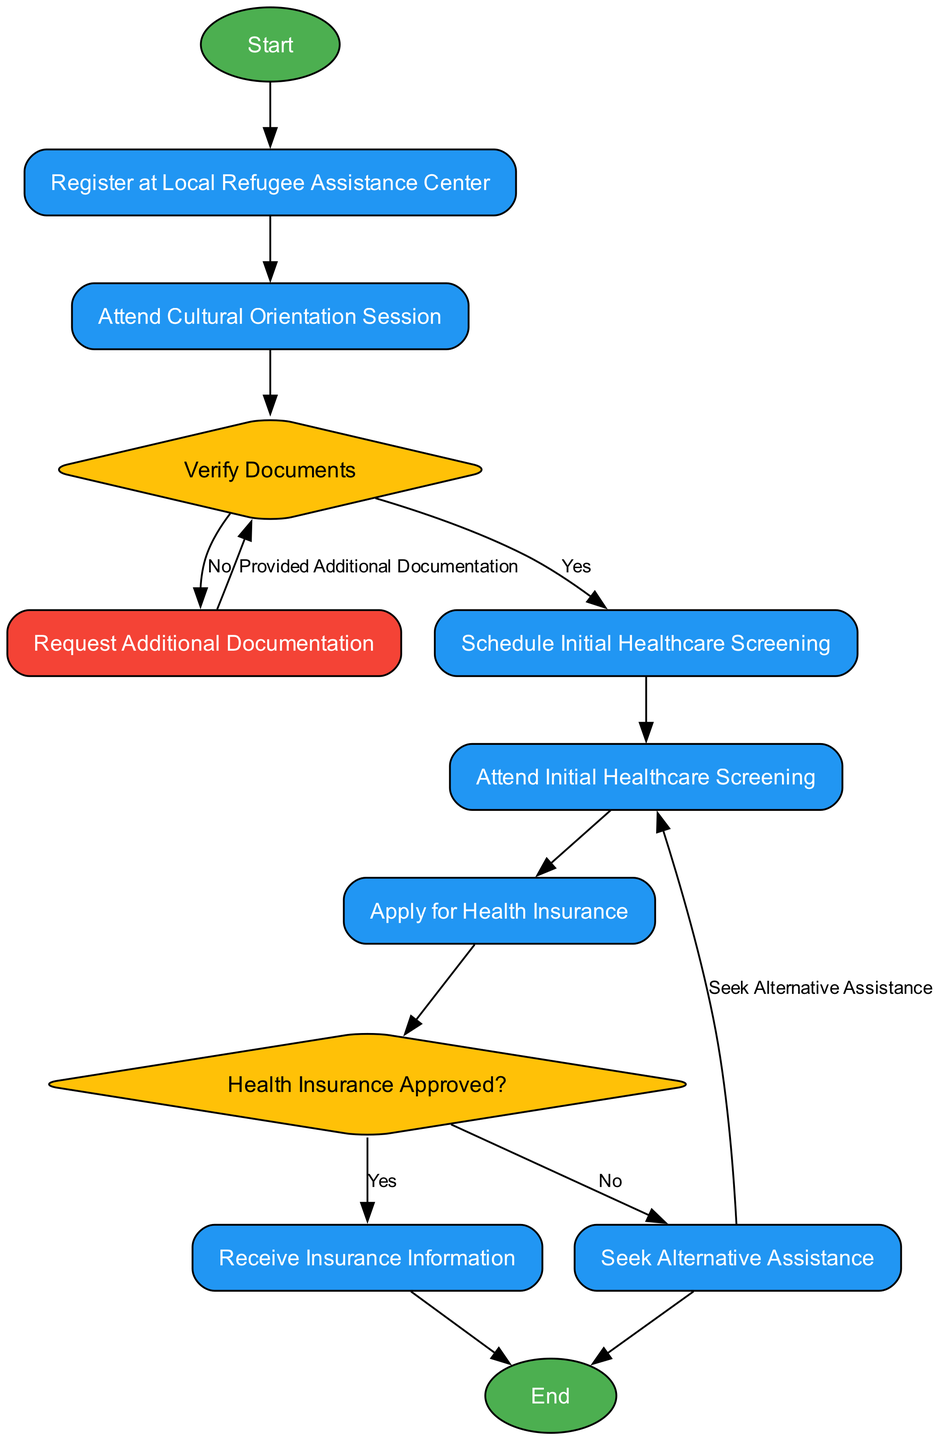What is the first step in the workflow? The first step is indicated by the "Start" node, which transitions to the "Register at Local Refugee Assistance Center".
Answer: Start How many decision points are in the workflow? There are two decision points: "Verify Documents" and "Health Insurance Approved?".
Answer: 2 What happens if document verification fails? If document verification fails, the next step is "Request Additional Documentation" where the refugee provides the necessary documents.
Answer: Request Additional Documentation What step follows after attending the initial healthcare screening? After attending the initial healthcare screening, the next step is "Apply for Health Insurance".
Answer: Apply for Health Insurance What type of workflow element is "Health Insurance Approved?" "Health Insurance Approved?" is a decision node, indicated by its shape and function in the workflow.
Answer: Decision What is the outcome if health insurance is denied? If health insurance is denied, the refugee must "Seek Alternative Assistance" from charitable organizations.
Answer: Seek Alternative Assistance Which node indicates the end of the healthcare access workflow? The end of the workflow is indicated by the "End" node, which follows the processes of receiving insurance information or seeking alternative assistance.
Answer: End What is the path taken if the refugee's health insurance is approved? If approved, the path leads directly to receiving insurance information and then to the end of the workflow.
Answer: Receive Insurance Information How many process steps are in the workflow? There are seven process steps: "Register at Local Refugee Assistance Center", "Attend Cultural Orientation Session", "Schedule Initial Healthcare Screening", "Attend Initial Healthcare Screening", "Apply for Health Insurance", "Receive Insurance Information", and "Seek Alternative Assistance".
Answer: 7 